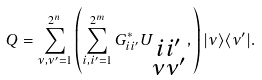Convert formula to latex. <formula><loc_0><loc_0><loc_500><loc_500>Q = \sum _ { \nu , \nu ^ { \prime } = 1 } ^ { 2 ^ { n } } \left ( \sum _ { i , i ^ { \prime } = 1 } ^ { 2 ^ { m } } G _ { i i ^ { \prime } } ^ { \ast } U _ { \substack { i i ^ { \prime } \\ \nu \nu ^ { \prime } } } , \right ) | \nu \rangle \langle \nu ^ { \prime } | .</formula> 